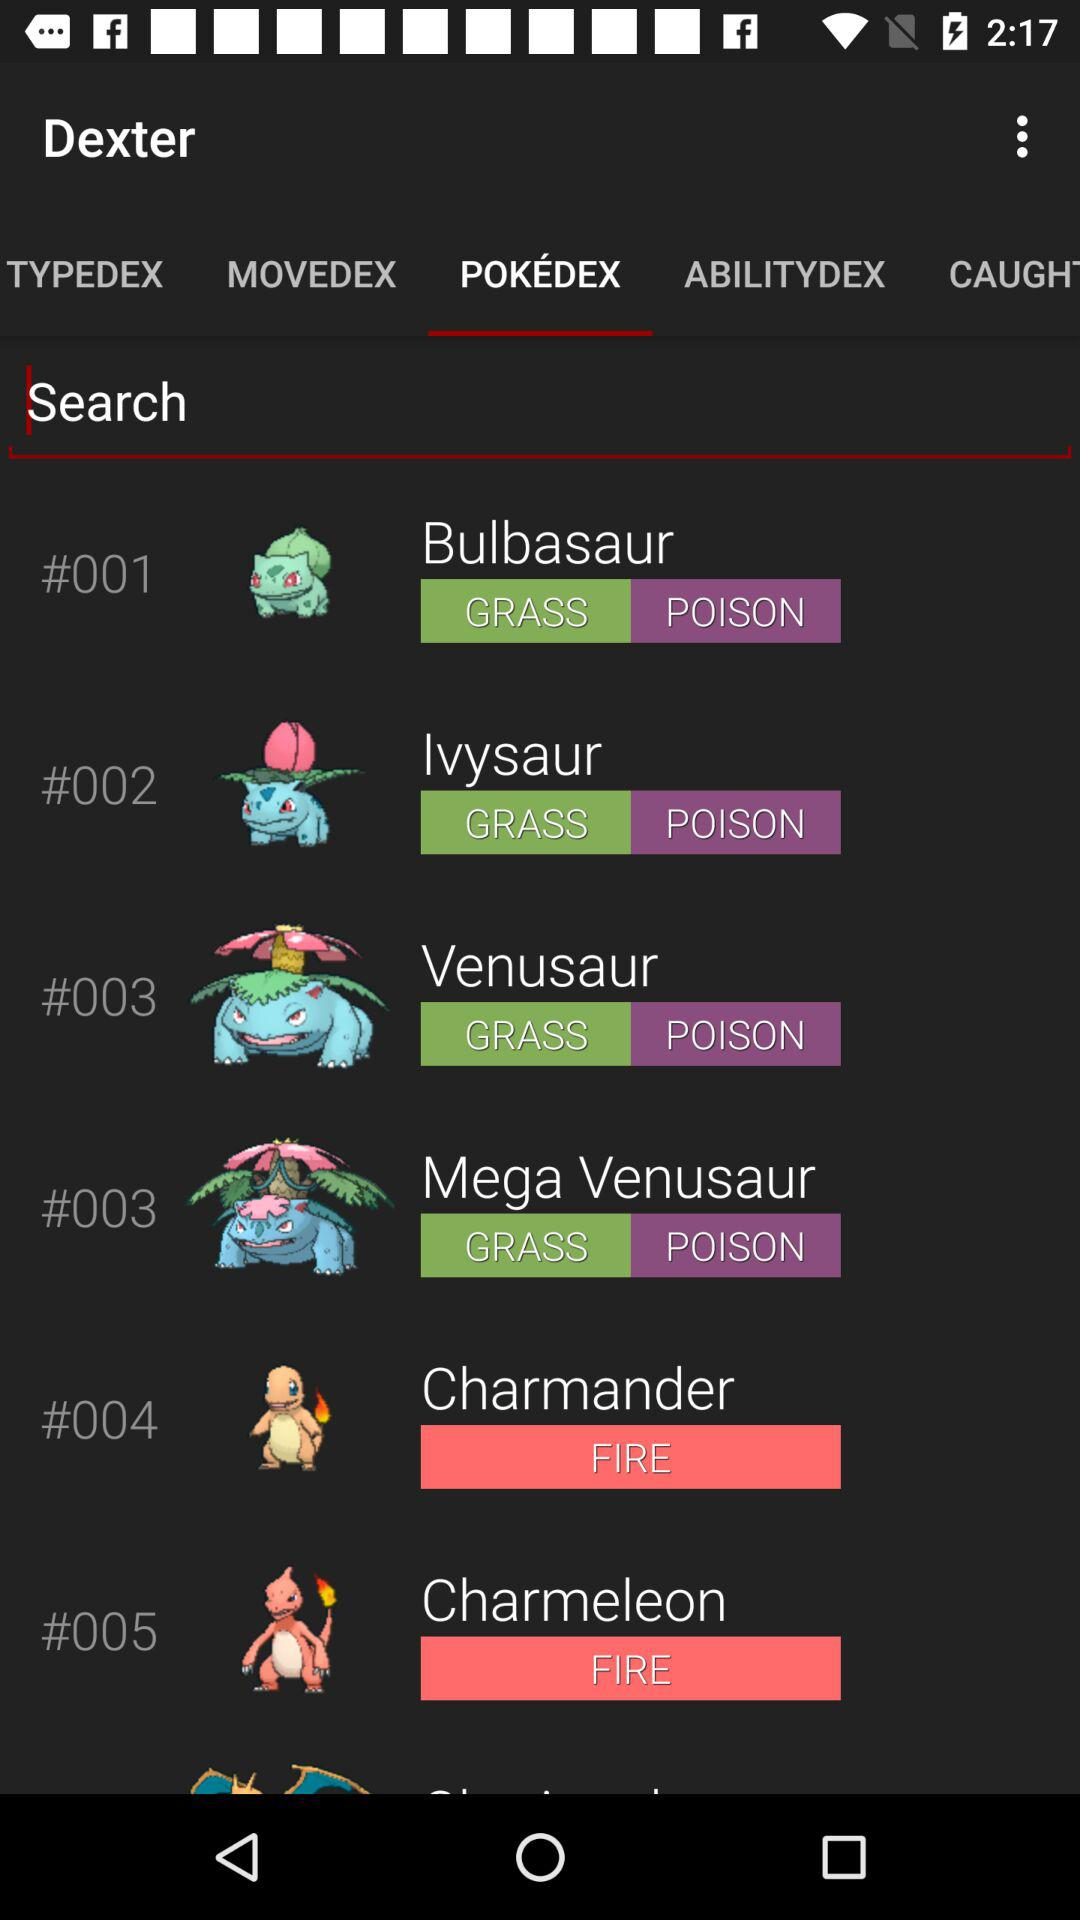Which tab is selected? The selected tab is "POKEDEX". 